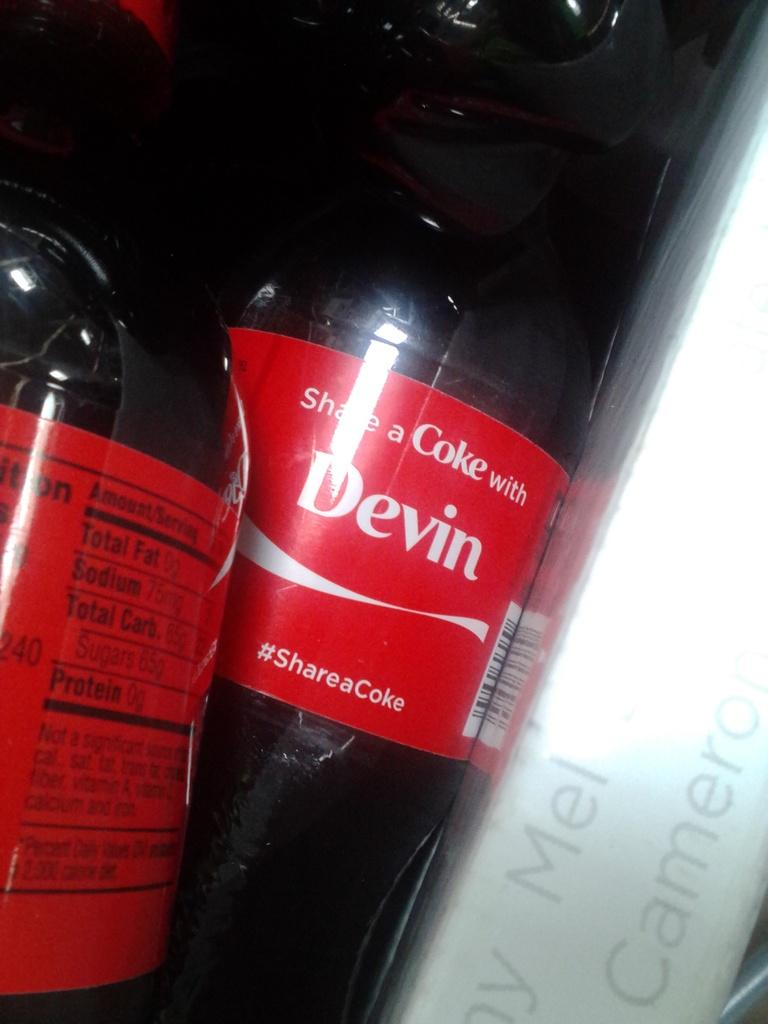<image>
Give a short and clear explanation of the subsequent image. A close up of a personalised coke bottle for Devin. 